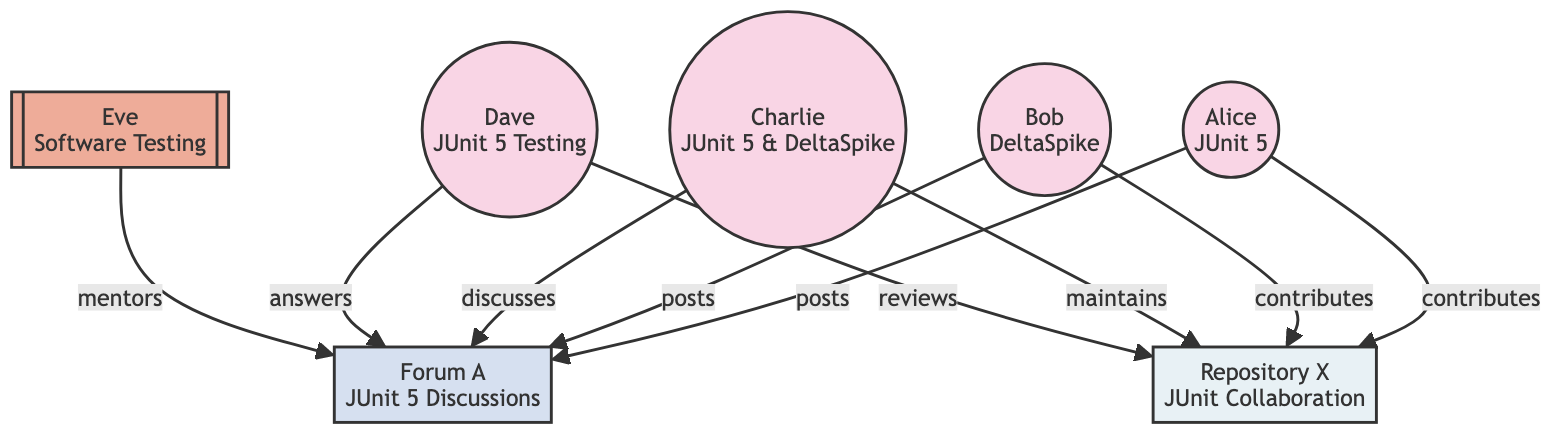What is the main expertise of Alice? The diagram indicates that Alice's expertise is specifically listed as "JUnit 5". This information can be found in her node.
Answer: JUnit 5 How many contributors are participating in the collaboration network? By examining the nodes in the diagram, we can count that there are four contributors: Alice, Bob, Charlie, and Dave.
Answer: 4 What relationship does Eve have with Forum A? Looking at the link from Eve to Forum A, it states that Eve "mentors" in this context, indicating her role related to discussions in Forum A.
Answer: mentors Who contributes to Repository X? By looking at the connections from contributors to Repository X in the diagram, we can identify that both Alice and Bob contribute, along with Charlie maintaining it and Dave reviewing it.
Answer: Alice and Bob Which node participates in the most relationships with Forum A? Analyzing the edges, we see multiple relationships linking contributors to Forum A, but Eve is the only one who doesn't post, thus all others (Alice, Bob, Charlie, and Dave) engage with it. Charlie discusses it adding a more complex interaction, though not necessarily most.
Answer: tie between Alice, Bob, Charlie, and Dave Which contributor has the most specialized expertise? Evaluating the expertise of the contributors, Charlie has a combination of "JUnit 5 & DeltaSpike", making his expertise broader than the others, while all others have singular focuses.
Answer: Charlie How many total edges are present in the directed graph? By counting the connections listed in the edges section - from Alice, Bob, Charlie, and Dave toward Forum A and Repository X, we sum them to achieve a total count of edges. This careful verification shows there are eight edges overall.
Answer: 8 What type of node is Forum A? The diagram clearly categorizes Forum A with the label "Forum", defining the type of node it represents within the collaboration context.
Answer: Forum 